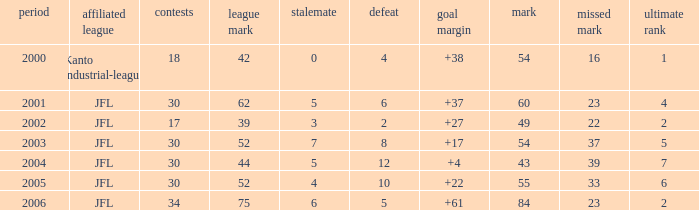Tell me the highest matches for point 43 and final rank less than 7 None. 